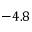Convert formula to latex. <formula><loc_0><loc_0><loc_500><loc_500>- 4 . 8</formula> 